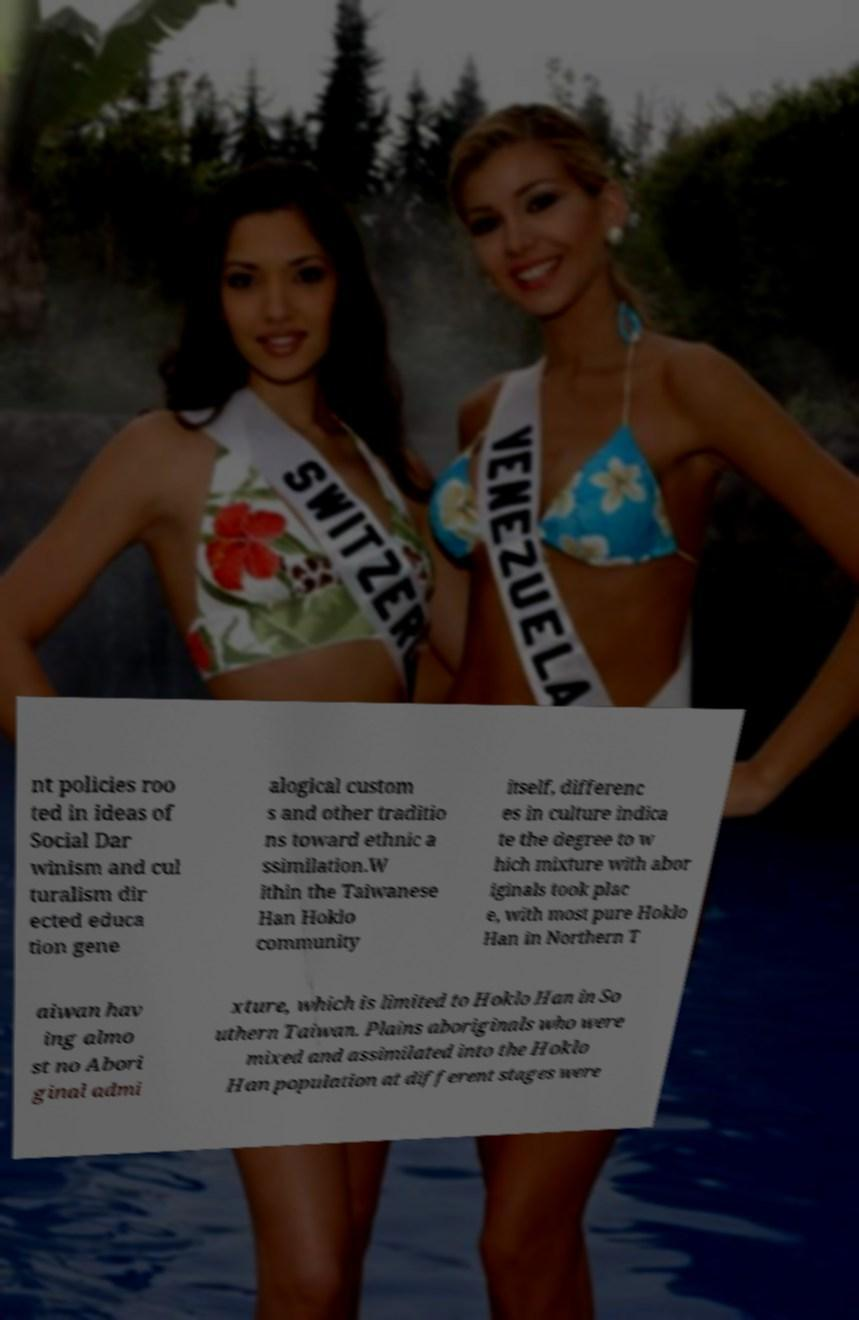Please identify and transcribe the text found in this image. nt policies roo ted in ideas of Social Dar winism and cul turalism dir ected educa tion gene alogical custom s and other traditio ns toward ethnic a ssimilation.W ithin the Taiwanese Han Hoklo community itself, differenc es in culture indica te the degree to w hich mixture with abor iginals took plac e, with most pure Hoklo Han in Northern T aiwan hav ing almo st no Abori ginal admi xture, which is limited to Hoklo Han in So uthern Taiwan. Plains aboriginals who were mixed and assimilated into the Hoklo Han population at different stages were 